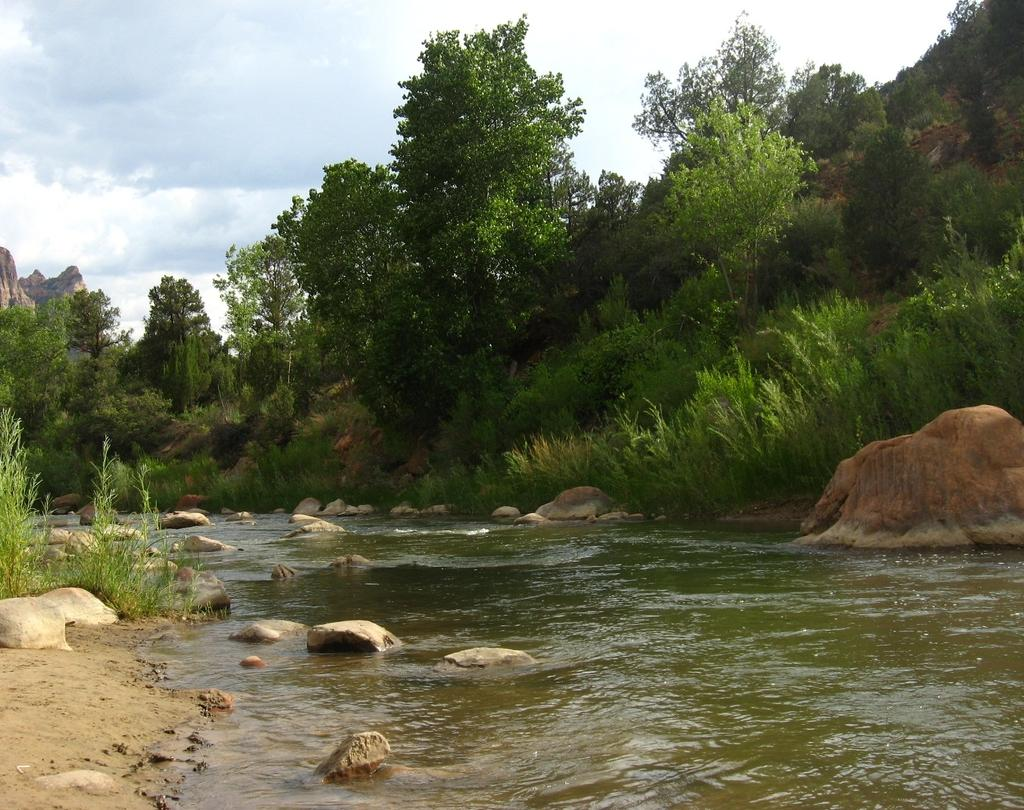What type of natural elements can be seen in the image? There are stones, water, plants, trees, and hills visible in the image. What else is present in the image besides natural elements? The sky is visible in the image. Can you describe the vegetation in the image? There are plants and trees present in the image. How many kittens are sitting on the plate in the image? There is no plate or kittens present in the image. What type of visitor can be seen interacting with the trees in the image? There are no visitors or interactions with trees depicted in the image. 